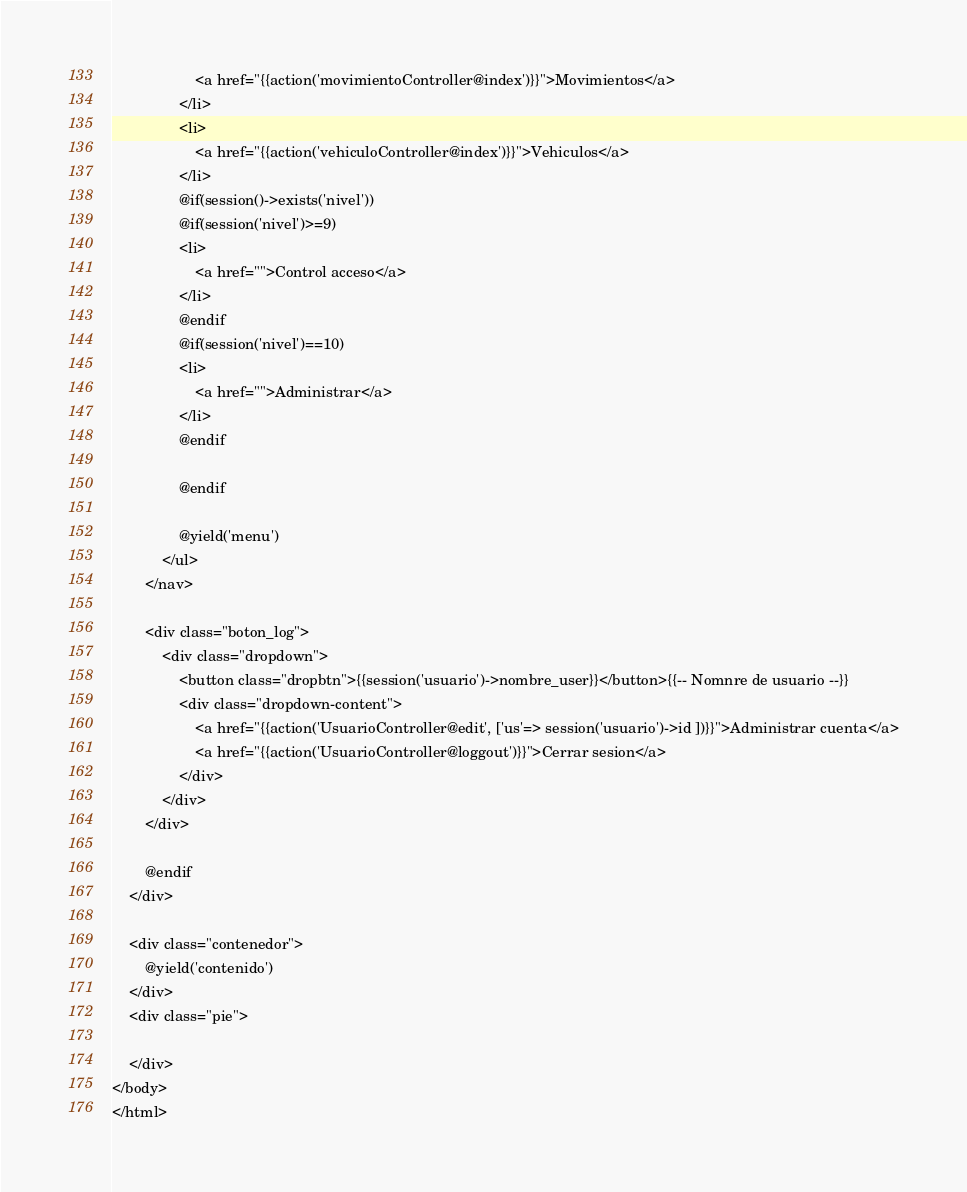<code> <loc_0><loc_0><loc_500><loc_500><_PHP_>                    <a href="{{action('movimientoController@index')}}">Movimientos</a>
                </li>
                <li>
                    <a href="{{action('vehiculoController@index')}}">Vehiculos</a>
                </li>
                @if(session()->exists('nivel'))
                @if(session('nivel')>=9)
                <li>
                    <a href="">Control acceso</a>
                </li>
                @endif
                @if(session('nivel')==10)
                <li>
                    <a href="">Administrar</a>
                </li>
                @endif

                @endif
                
                @yield('menu')
            </ul>
        </nav>

        <div class="boton_log">
            <div class="dropdown">
                <button class="dropbtn">{{session('usuario')->nombre_user}}</button>{{-- Nomnre de usuario --}}
                <div class="dropdown-content">
                    <a href="{{action('UsuarioController@edit', ['us'=> session('usuario')->id ])}}">Administrar cuenta</a>
                    <a href="{{action('UsuarioController@loggout')}}">Cerrar sesion</a>
                </div>
            </div>
        </div>

        @endif
    </div>

    <div class="contenedor">
        @yield('contenido')
    </div>
    <div class="pie">

    </div>
</body>
</html>



</code> 